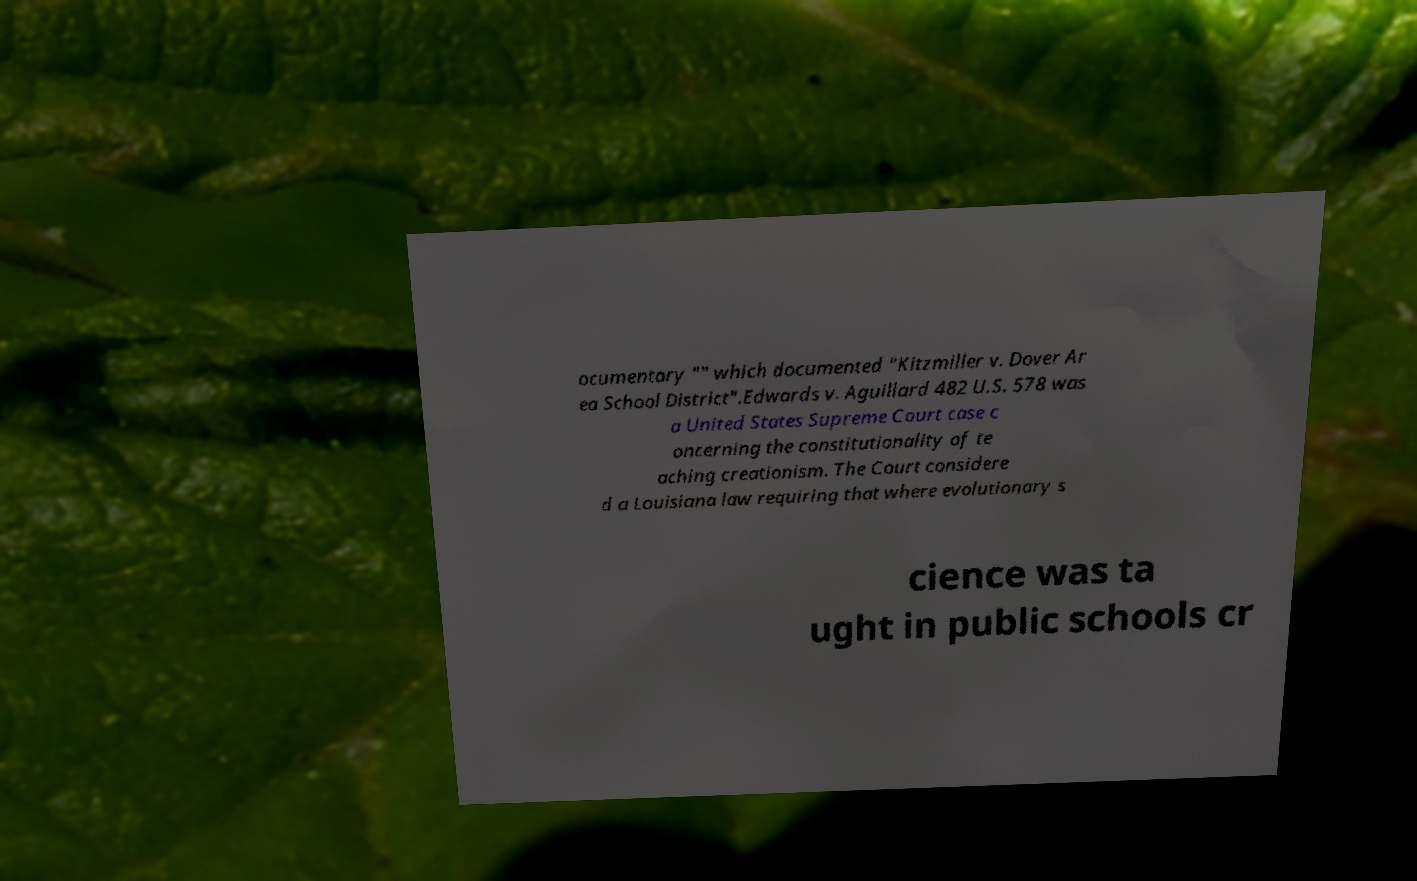I need the written content from this picture converted into text. Can you do that? ocumentary "" which documented "Kitzmiller v. Dover Ar ea School District".Edwards v. Aguillard 482 U.S. 578 was a United States Supreme Court case c oncerning the constitutionality of te aching creationism. The Court considere d a Louisiana law requiring that where evolutionary s cience was ta ught in public schools cr 